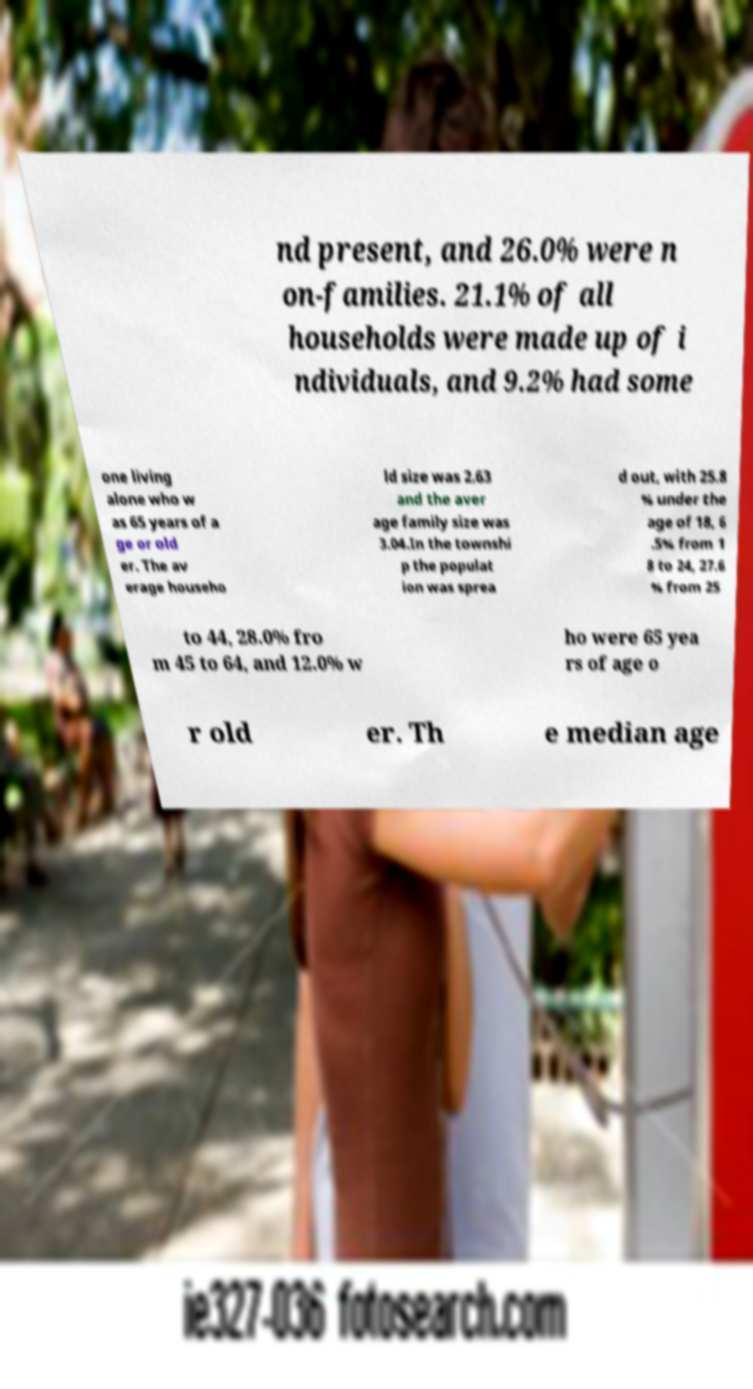Could you extract and type out the text from this image? nd present, and 26.0% were n on-families. 21.1% of all households were made up of i ndividuals, and 9.2% had some one living alone who w as 65 years of a ge or old er. The av erage househo ld size was 2.63 and the aver age family size was 3.04.In the townshi p the populat ion was sprea d out, with 25.8 % under the age of 18, 6 .5% from 1 8 to 24, 27.6 % from 25 to 44, 28.0% fro m 45 to 64, and 12.0% w ho were 65 yea rs of age o r old er. Th e median age 